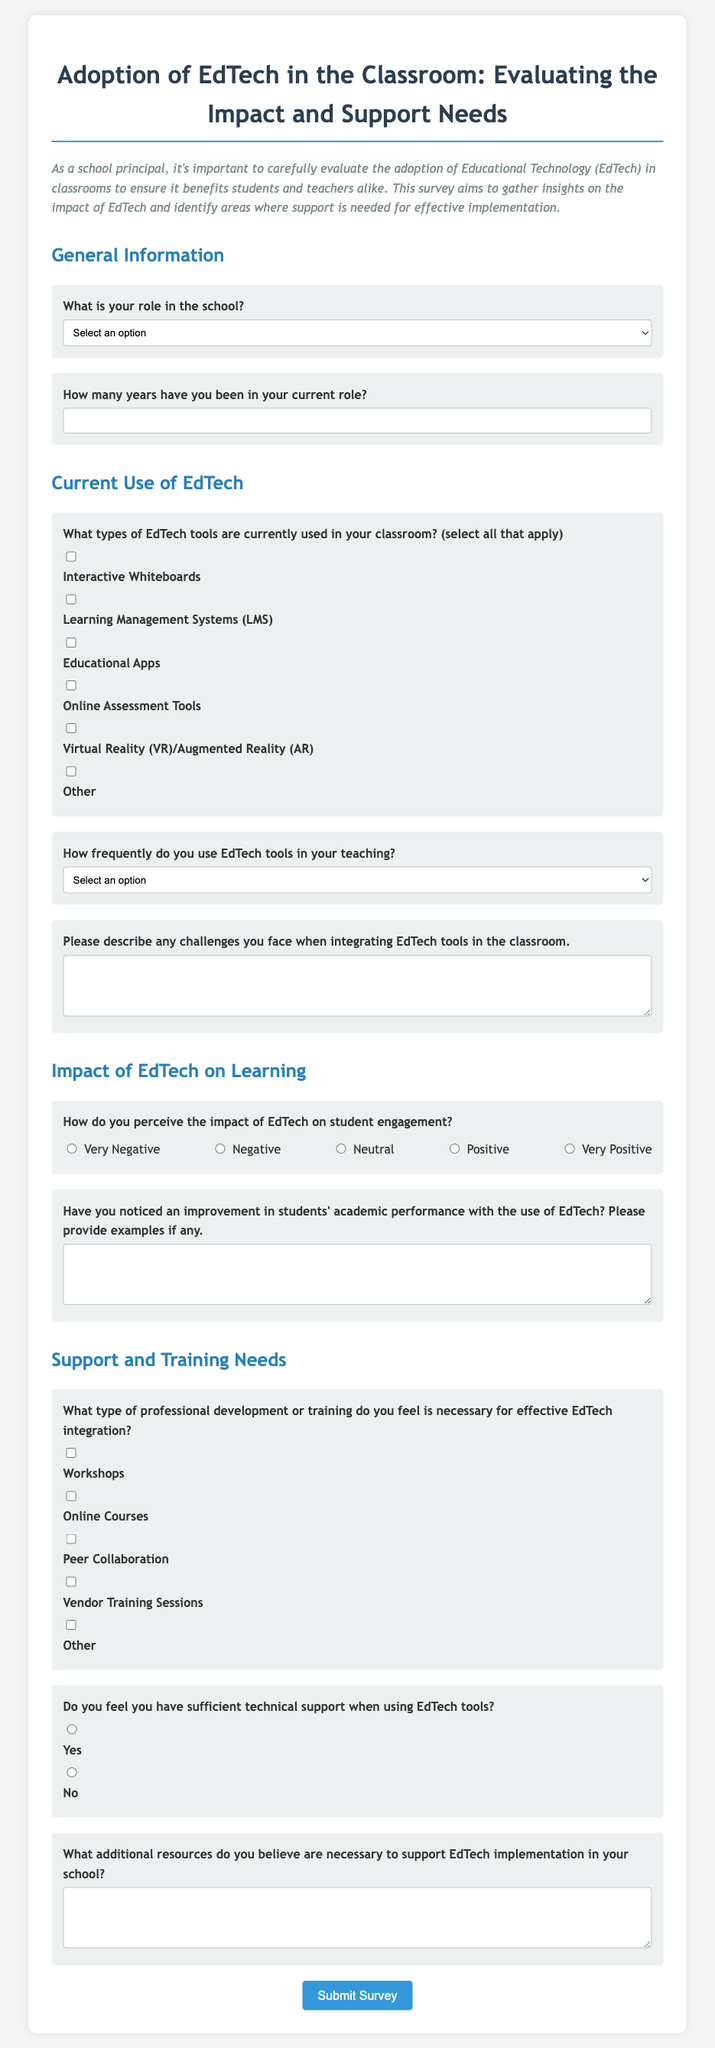What is the title of the survey? The title of the survey is stated at the top of the document.
Answer: Adoption of EdTech in the Classroom: Evaluating the Impact and Support Needs What is the first question in the General Information section? The first question in the General Information section is about the respondent's role in the school.
Answer: What is your role in the school? How many years of experience does the survey ask for? The survey asks for the number of years the respondent has been in their current role.
Answer: How many years have you been in your current role? What is the last question in the Support and Training Needs section? The last question in the Support and Training Needs section asks for additional resources needed for EdTech implementation.
Answer: What additional resources do you believe are necessary to support EdTech implementation in your school? What type of professional development does the survey suggest for EdTech integration? The survey includes various options for professional development related to EdTech integration.
Answer: Workshops What is the frequency option that is listed as "Never"? The survey provides multiple options for how frequently EdTech tools are used, including the option "Never."
Answer: Never What is required from the respondent for the impact of EdTech on student engagement? The survey requires the respondent to select a perception regarding the impact of EdTech.
Answer: Required selection Does the survey ask about the usage of Online Assessment Tools? It specifically asks about the types of EdTech tools used in the classroom, including Online Assessment Tools.
Answer: Yes What format does the survey use for gathering opinions on student engagement? The survey uses a scale of radio buttons to gauge opinions on student engagement.
Answer: Radio buttons 